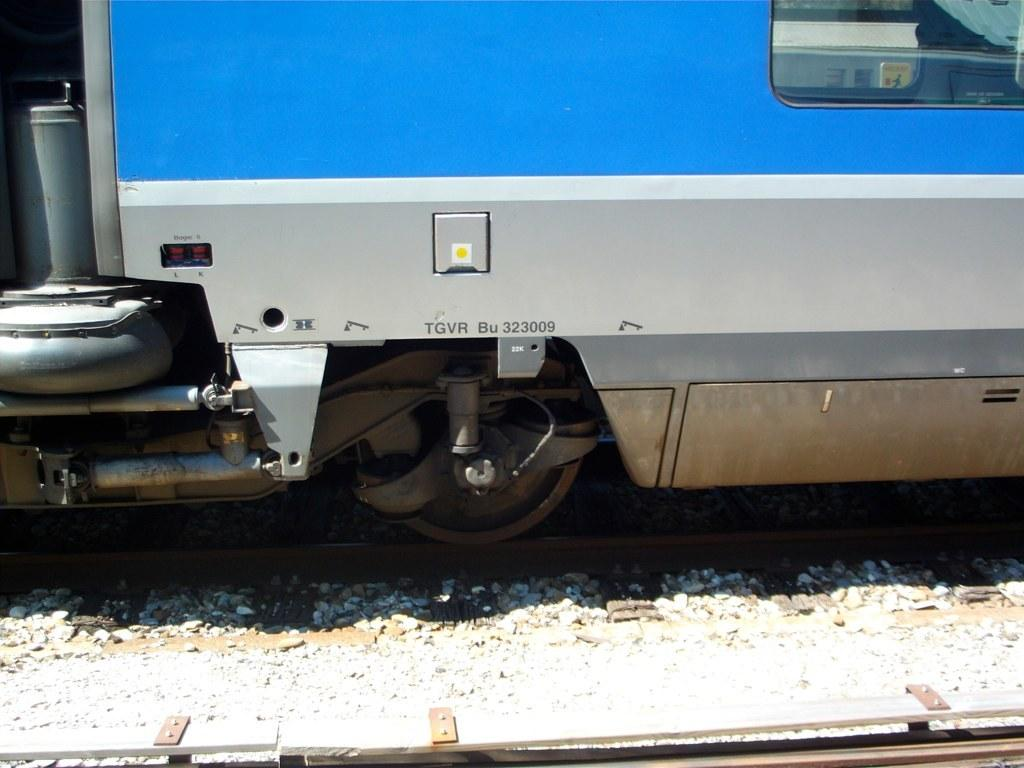What is the main subject of the image? The main subject of the image is a train. Can you describe the train's location in the image? The train is on a track. What can be observed about the track in the image? The track appears to be truncated. What type of book is the governor reading on the floor in the image? There is no book or governor present in the image; it only features a train on a track. 